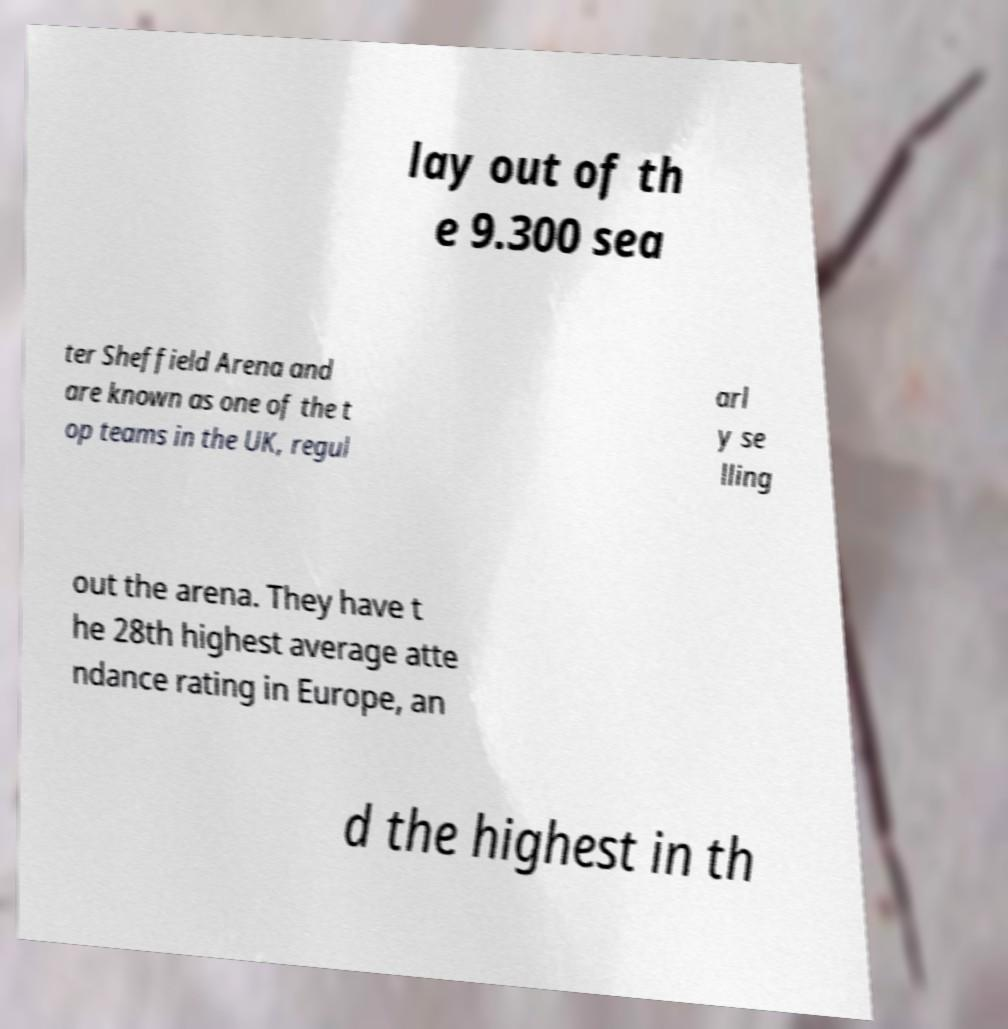For documentation purposes, I need the text within this image transcribed. Could you provide that? lay out of th e 9.300 sea ter Sheffield Arena and are known as one of the t op teams in the UK, regul arl y se lling out the arena. They have t he 28th highest average atte ndance rating in Europe, an d the highest in th 